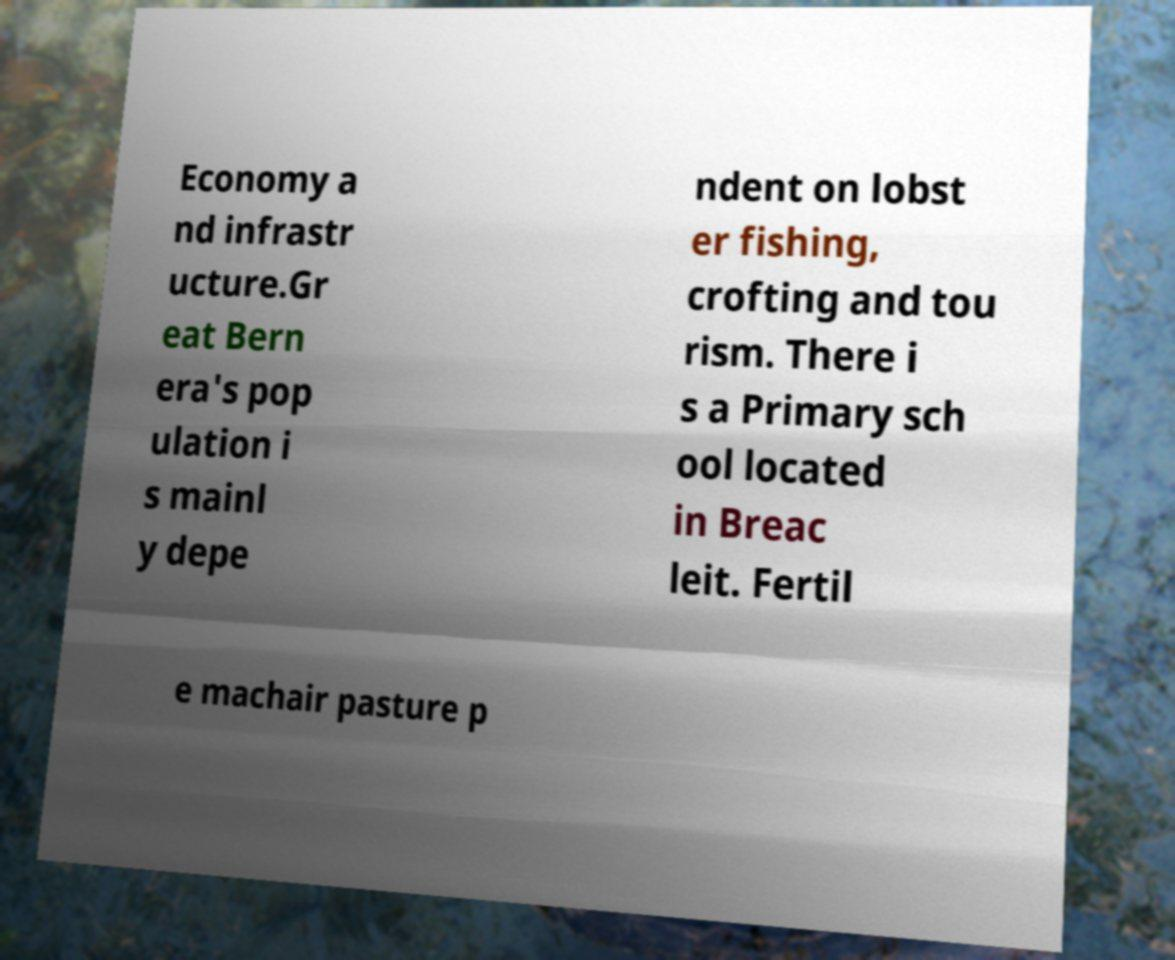I need the written content from this picture converted into text. Can you do that? Economy a nd infrastr ucture.Gr eat Bern era's pop ulation i s mainl y depe ndent on lobst er fishing, crofting and tou rism. There i s a Primary sch ool located in Breac leit. Fertil e machair pasture p 